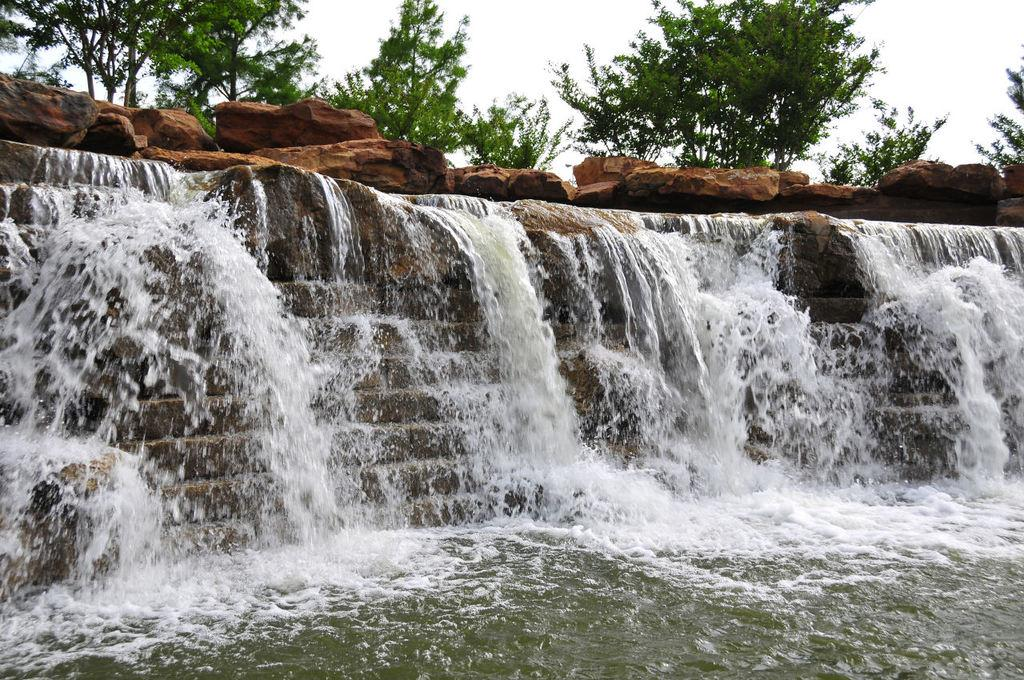What is the main feature in the front of the image? There is a waterfall in the front of the image. What can be seen in the background of the image? There are stones and trees in the background of the image. How would you describe the sky in the image? The sky is cloudy in the image. What type of spade is being used to select rocks in the image? There is no spade or rock selection activity depicted in the image. What kind of calculator can be seen on the tree in the image? There is no calculator present in the image. 